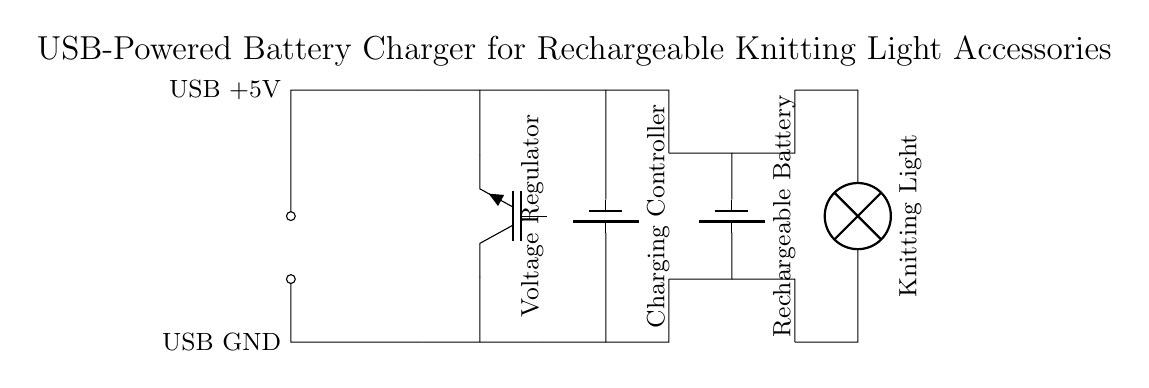What is the primary input voltage of this charger? The primary input voltage is provided by the USB, which is labeled as +5V in the diagram.
Answer: 5V What component regulates voltage in this circuit? The voltage regulator is the component responsible for ensuring that the output voltage is stable and appropriate for the downstream components. It is clearly labeled in the diagram.
Answer: Voltage Regulator What does the charging controller do in this circuit? The charging controller manages the process of charging the rechargeable battery. It ensures that the battery charges safely and efficiently without overloading.
Answer: Charging Controller How many batteries are included in this circuit design? Two battery symbols can be seen in the diagram, indicating that there are two batteries involved: one for the rechargeable battery and one as a symbol for a general battery in the charging system.
Answer: Two What is the output device connected to the circuit? The output device is the knitting light, which is directly connected to the circuit, producing light for knitting purposes.
Answer: Knitting Light Which component receives power from the USB? The USB powers the voltage regulator, which is the first component connected to the USB input, thus it receives the power directly.
Answer: Voltage Regulator What is the purpose of the rechargeable battery in this circuit? The rechargeable battery stores energy and provides power to the knitting light when it is in use, allowing for portability.
Answer: Energy Storage 